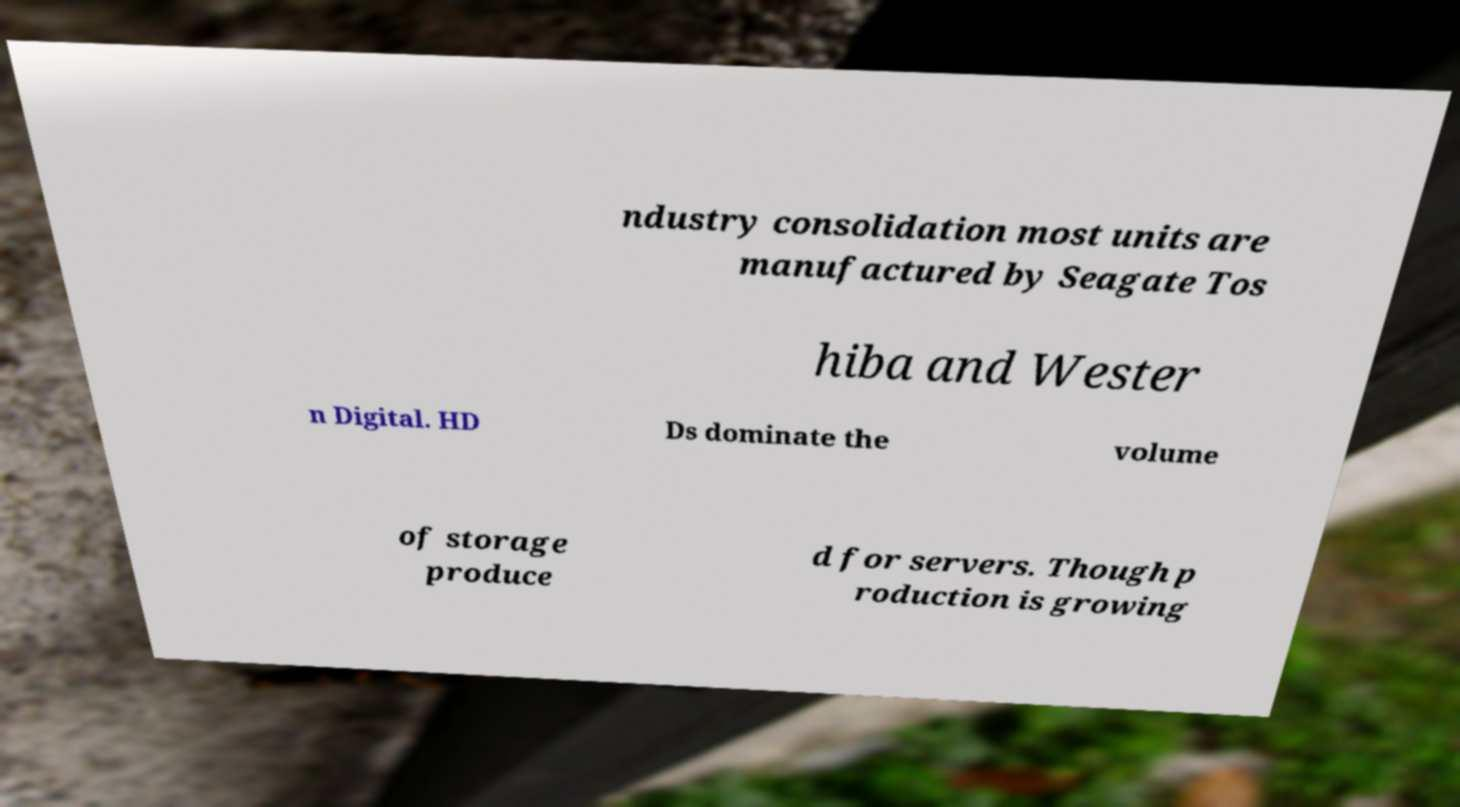Please read and relay the text visible in this image. What does it say? ndustry consolidation most units are manufactured by Seagate Tos hiba and Wester n Digital. HD Ds dominate the volume of storage produce d for servers. Though p roduction is growing 